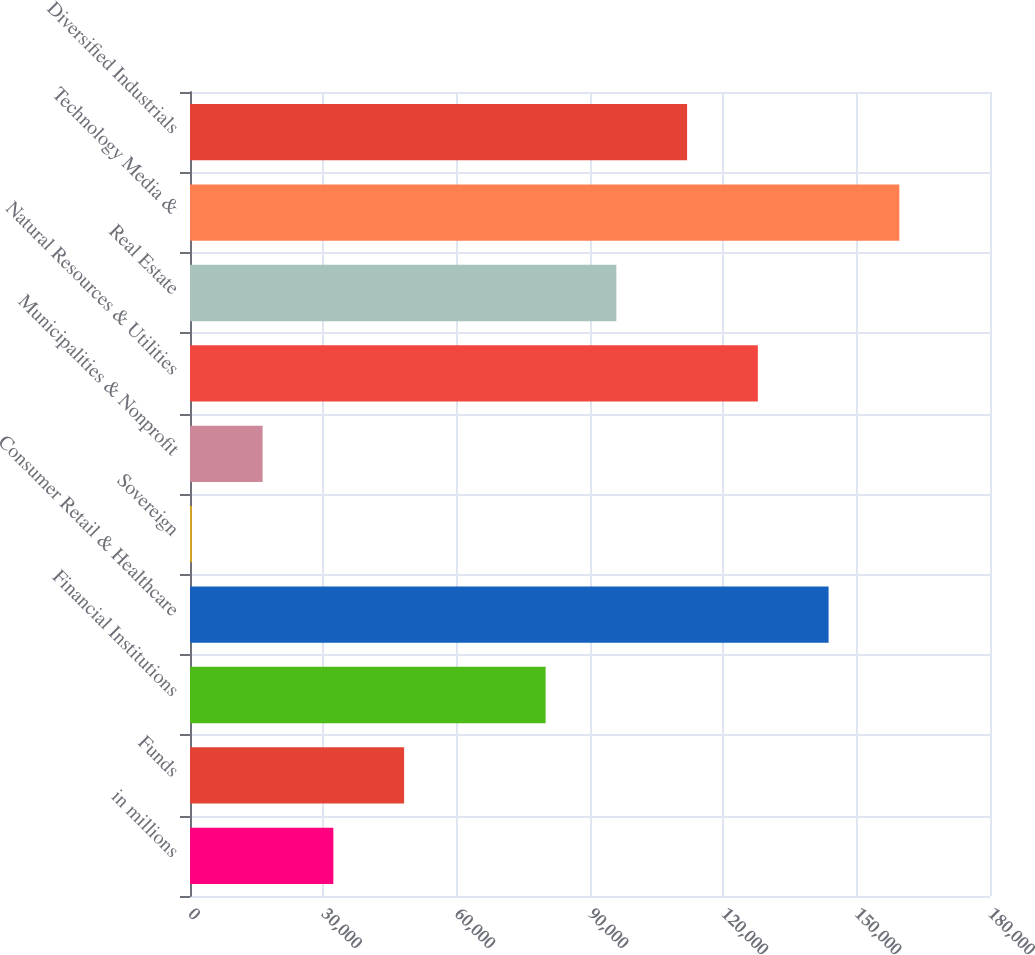Convert chart. <chart><loc_0><loc_0><loc_500><loc_500><bar_chart><fcel>in millions<fcel>Funds<fcel>Financial Institutions<fcel>Consumer Retail & Healthcare<fcel>Sovereign<fcel>Municipalities & Nonprofit<fcel>Natural Resources & Utilities<fcel>Real Estate<fcel>Technology Media &<fcel>Diversified Industrials<nl><fcel>32255.6<fcel>48173.9<fcel>80010.5<fcel>143684<fcel>419<fcel>16337.3<fcel>127765<fcel>95928.8<fcel>159602<fcel>111847<nl></chart> 